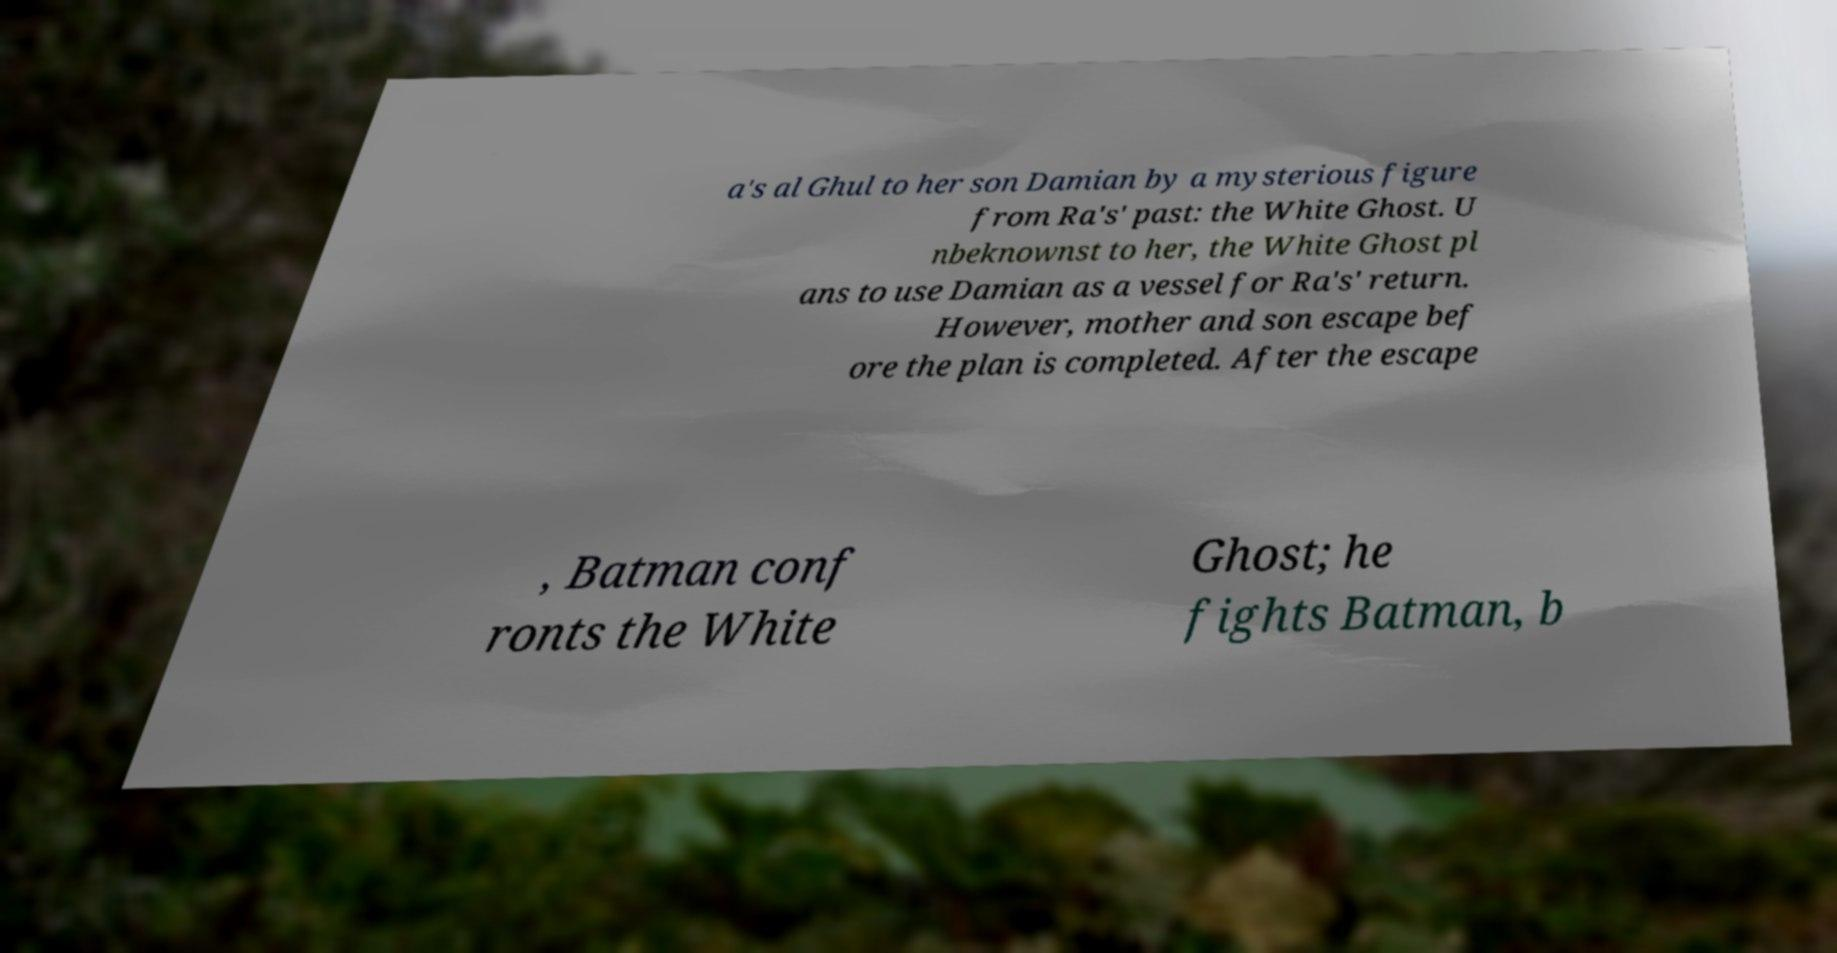Could you extract and type out the text from this image? a's al Ghul to her son Damian by a mysterious figure from Ra's' past: the White Ghost. U nbeknownst to her, the White Ghost pl ans to use Damian as a vessel for Ra's' return. However, mother and son escape bef ore the plan is completed. After the escape , Batman conf ronts the White Ghost; he fights Batman, b 